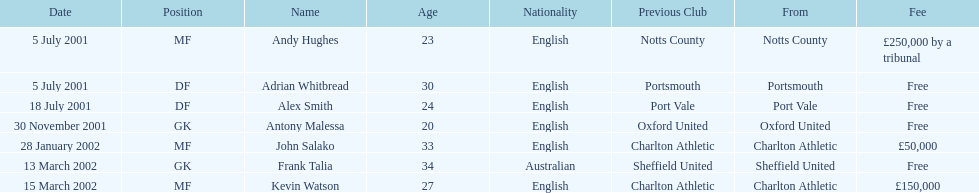What is the total number of free fees? 4. 